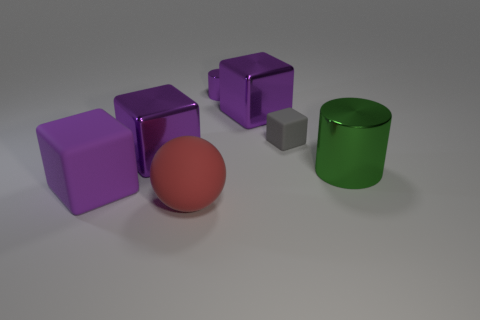What size is the rubber block in front of the cylinder that is in front of the rubber cube on the right side of the small purple metal cylinder?
Keep it short and to the point. Large. There is a rubber object that is both in front of the small matte object and behind the big red rubber ball; what is its size?
Give a very brief answer. Large. There is a large metal cube that is right of the big red sphere; is it the same color as the large metallic object left of the red thing?
Keep it short and to the point. Yes. How many large red things are to the right of the large sphere?
Ensure brevity in your answer.  0. There is a tiny thing that is on the right side of the purple cube that is behind the gray matte object; is there a large purple metal cube that is behind it?
Your answer should be very brief. Yes. How many other green metal cylinders have the same size as the green cylinder?
Make the answer very short. 0. What material is the tiny cylinder behind the metal block to the left of the red matte ball?
Make the answer very short. Metal. What shape is the rubber object that is on the right side of the big rubber object that is in front of the cube that is in front of the large metal cylinder?
Make the answer very short. Cube. There is a tiny object behind the tiny gray object; is it the same shape as the large metallic thing that is on the right side of the small matte thing?
Your answer should be compact. Yes. How many other things are made of the same material as the big green thing?
Your answer should be compact. 3. 